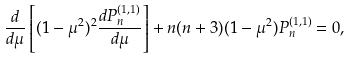<formula> <loc_0><loc_0><loc_500><loc_500>\frac { d } { d \mu } \left [ ( 1 - \mu ^ { 2 } ) ^ { 2 } \frac { d P _ { n } ^ { ( 1 , 1 ) } } { d \mu } \right ] + n ( n + 3 ) ( 1 - \mu ^ { 2 } ) P _ { n } ^ { ( 1 , 1 ) } = 0 ,</formula> 